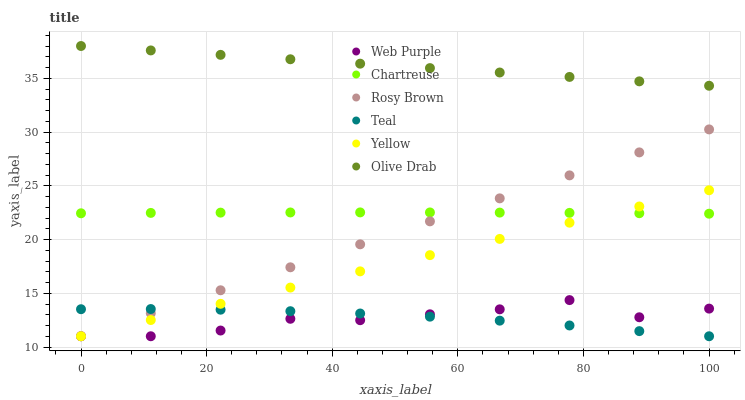Does Web Purple have the minimum area under the curve?
Answer yes or no. Yes. Does Olive Drab have the maximum area under the curve?
Answer yes or no. Yes. Does Chartreuse have the minimum area under the curve?
Answer yes or no. No. Does Chartreuse have the maximum area under the curve?
Answer yes or no. No. Is Yellow the smoothest?
Answer yes or no. Yes. Is Web Purple the roughest?
Answer yes or no. Yes. Is Chartreuse the smoothest?
Answer yes or no. No. Is Chartreuse the roughest?
Answer yes or no. No. Does Rosy Brown have the lowest value?
Answer yes or no. Yes. Does Chartreuse have the lowest value?
Answer yes or no. No. Does Olive Drab have the highest value?
Answer yes or no. Yes. Does Chartreuse have the highest value?
Answer yes or no. No. Is Teal less than Chartreuse?
Answer yes or no. Yes. Is Olive Drab greater than Yellow?
Answer yes or no. Yes. Does Web Purple intersect Teal?
Answer yes or no. Yes. Is Web Purple less than Teal?
Answer yes or no. No. Is Web Purple greater than Teal?
Answer yes or no. No. Does Teal intersect Chartreuse?
Answer yes or no. No. 